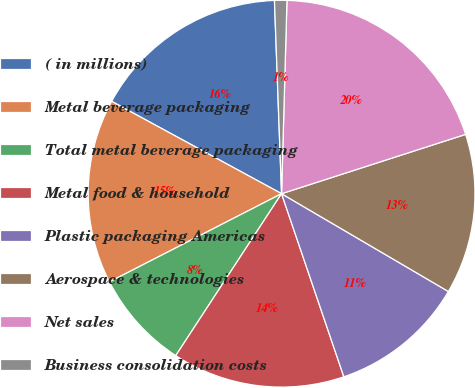<chart> <loc_0><loc_0><loc_500><loc_500><pie_chart><fcel>( in millions)<fcel>Metal beverage packaging<fcel>Total metal beverage packaging<fcel>Metal food & household<fcel>Plastic packaging Americas<fcel>Aerospace & technologies<fcel>Net sales<fcel>Business consolidation costs<nl><fcel>16.49%<fcel>15.46%<fcel>8.25%<fcel>14.43%<fcel>11.34%<fcel>13.4%<fcel>19.59%<fcel>1.03%<nl></chart> 